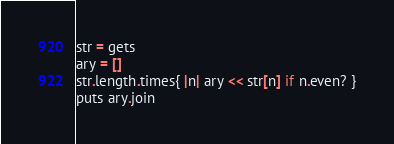<code> <loc_0><loc_0><loc_500><loc_500><_Ruby_>str = gets
ary = []
str.length.times{ |n| ary << str[n] if n.even? }
puts ary.join</code> 